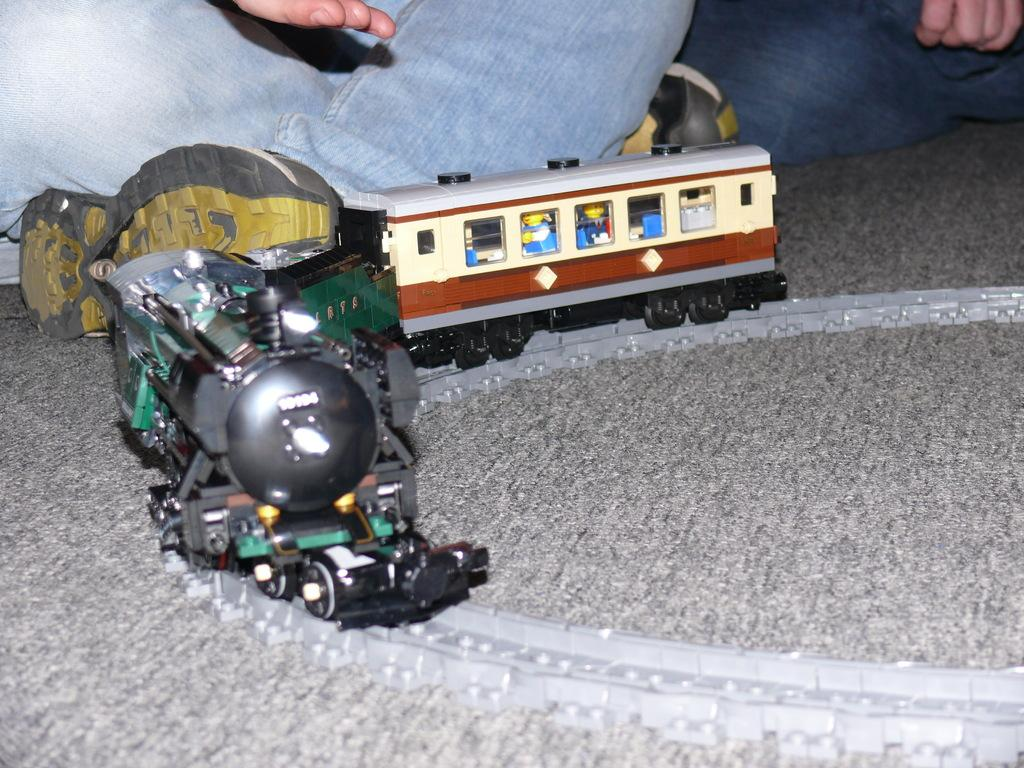What type of toy is present in the image? There is a train toy in the image. Can you describe any body parts visible in the image? A person's hand and leg are visible at the top of the image. What type of paper is being used for the voyage in the image? There is no paper or voyage present in the image; it only features a train toy and a person's hand and leg. 